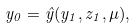<formula> <loc_0><loc_0><loc_500><loc_500>y _ { 0 } = \hat { y } ( y _ { 1 } , z _ { 1 } , \mu ) ,</formula> 